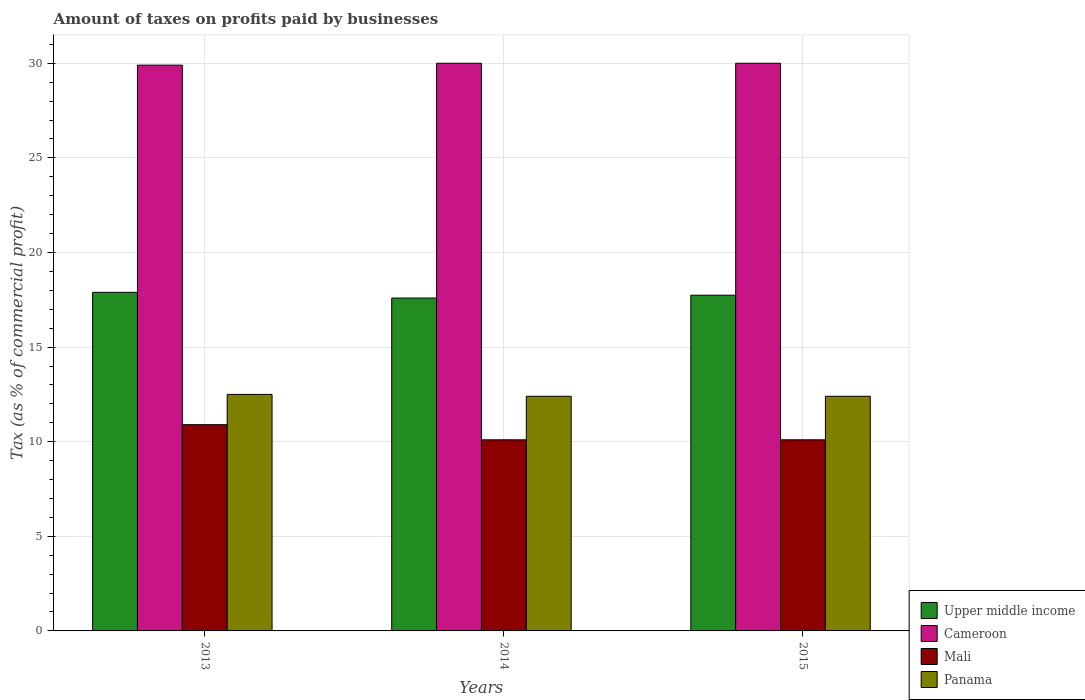How many groups of bars are there?
Your response must be concise. 3. Are the number of bars per tick equal to the number of legend labels?
Provide a short and direct response. Yes. Are the number of bars on each tick of the X-axis equal?
Offer a terse response. Yes. How many bars are there on the 3rd tick from the right?
Provide a succinct answer. 4. In how many cases, is the number of bars for a given year not equal to the number of legend labels?
Offer a terse response. 0. Across all years, what is the maximum percentage of taxes paid by businesses in Cameroon?
Offer a terse response. 30. Across all years, what is the minimum percentage of taxes paid by businesses in Panama?
Your answer should be very brief. 12.4. What is the total percentage of taxes paid by businesses in Mali in the graph?
Your response must be concise. 31.1. What is the difference between the percentage of taxes paid by businesses in Panama in 2013 and that in 2014?
Keep it short and to the point. 0.1. What is the difference between the percentage of taxes paid by businesses in Panama in 2015 and the percentage of taxes paid by businesses in Mali in 2014?
Offer a terse response. 2.3. What is the average percentage of taxes paid by businesses in Upper middle income per year?
Your answer should be very brief. 17.74. In the year 2014, what is the difference between the percentage of taxes paid by businesses in Panama and percentage of taxes paid by businesses in Mali?
Your answer should be very brief. 2.3. In how many years, is the percentage of taxes paid by businesses in Cameroon greater than 30 %?
Offer a very short reply. 0. What is the ratio of the percentage of taxes paid by businesses in Mali in 2014 to that in 2015?
Give a very brief answer. 1. Is the percentage of taxes paid by businesses in Panama in 2014 less than that in 2015?
Offer a terse response. No. What is the difference between the highest and the lowest percentage of taxes paid by businesses in Upper middle income?
Offer a terse response. 0.3. In how many years, is the percentage of taxes paid by businesses in Cameroon greater than the average percentage of taxes paid by businesses in Cameroon taken over all years?
Ensure brevity in your answer.  2. Is the sum of the percentage of taxes paid by businesses in Mali in 2013 and 2014 greater than the maximum percentage of taxes paid by businesses in Cameroon across all years?
Offer a very short reply. No. What does the 4th bar from the left in 2015 represents?
Your response must be concise. Panama. What does the 1st bar from the right in 2013 represents?
Ensure brevity in your answer.  Panama. Is it the case that in every year, the sum of the percentage of taxes paid by businesses in Panama and percentage of taxes paid by businesses in Cameroon is greater than the percentage of taxes paid by businesses in Upper middle income?
Your answer should be compact. Yes. Are all the bars in the graph horizontal?
Keep it short and to the point. No. Does the graph contain grids?
Provide a succinct answer. Yes. Where does the legend appear in the graph?
Your answer should be compact. Bottom right. What is the title of the graph?
Ensure brevity in your answer.  Amount of taxes on profits paid by businesses. What is the label or title of the Y-axis?
Your response must be concise. Tax (as % of commercial profit). What is the Tax (as % of commercial profit) in Upper middle income in 2013?
Provide a short and direct response. 17.89. What is the Tax (as % of commercial profit) in Cameroon in 2013?
Your answer should be very brief. 29.9. What is the Tax (as % of commercial profit) of Mali in 2013?
Your response must be concise. 10.9. What is the Tax (as % of commercial profit) of Upper middle income in 2014?
Keep it short and to the point. 17.59. What is the Tax (as % of commercial profit) of Cameroon in 2014?
Your answer should be compact. 30. What is the Tax (as % of commercial profit) in Mali in 2014?
Offer a very short reply. 10.1. What is the Tax (as % of commercial profit) of Upper middle income in 2015?
Give a very brief answer. 17.74. What is the Tax (as % of commercial profit) in Cameroon in 2015?
Provide a short and direct response. 30. Across all years, what is the maximum Tax (as % of commercial profit) of Upper middle income?
Give a very brief answer. 17.89. Across all years, what is the maximum Tax (as % of commercial profit) in Cameroon?
Your answer should be compact. 30. Across all years, what is the maximum Tax (as % of commercial profit) of Mali?
Give a very brief answer. 10.9. Across all years, what is the maximum Tax (as % of commercial profit) of Panama?
Your response must be concise. 12.5. Across all years, what is the minimum Tax (as % of commercial profit) in Upper middle income?
Provide a short and direct response. 17.59. Across all years, what is the minimum Tax (as % of commercial profit) of Cameroon?
Give a very brief answer. 29.9. Across all years, what is the minimum Tax (as % of commercial profit) in Mali?
Offer a very short reply. 10.1. What is the total Tax (as % of commercial profit) in Upper middle income in the graph?
Give a very brief answer. 53.23. What is the total Tax (as % of commercial profit) in Cameroon in the graph?
Make the answer very short. 89.9. What is the total Tax (as % of commercial profit) in Mali in the graph?
Your answer should be very brief. 31.1. What is the total Tax (as % of commercial profit) of Panama in the graph?
Make the answer very short. 37.3. What is the difference between the Tax (as % of commercial profit) in Upper middle income in 2013 and that in 2014?
Your answer should be very brief. 0.3. What is the difference between the Tax (as % of commercial profit) in Cameroon in 2013 and that in 2014?
Give a very brief answer. -0.1. What is the difference between the Tax (as % of commercial profit) of Upper middle income in 2013 and that in 2015?
Keep it short and to the point. 0.15. What is the difference between the Tax (as % of commercial profit) in Cameroon in 2013 and that in 2015?
Offer a very short reply. -0.1. What is the difference between the Tax (as % of commercial profit) of Panama in 2013 and that in 2015?
Your answer should be compact. 0.1. What is the difference between the Tax (as % of commercial profit) in Upper middle income in 2013 and the Tax (as % of commercial profit) in Cameroon in 2014?
Offer a terse response. -12.11. What is the difference between the Tax (as % of commercial profit) of Upper middle income in 2013 and the Tax (as % of commercial profit) of Mali in 2014?
Ensure brevity in your answer.  7.79. What is the difference between the Tax (as % of commercial profit) of Upper middle income in 2013 and the Tax (as % of commercial profit) of Panama in 2014?
Your response must be concise. 5.49. What is the difference between the Tax (as % of commercial profit) of Cameroon in 2013 and the Tax (as % of commercial profit) of Mali in 2014?
Your response must be concise. 19.8. What is the difference between the Tax (as % of commercial profit) of Mali in 2013 and the Tax (as % of commercial profit) of Panama in 2014?
Your response must be concise. -1.5. What is the difference between the Tax (as % of commercial profit) in Upper middle income in 2013 and the Tax (as % of commercial profit) in Cameroon in 2015?
Offer a terse response. -12.11. What is the difference between the Tax (as % of commercial profit) of Upper middle income in 2013 and the Tax (as % of commercial profit) of Mali in 2015?
Your answer should be very brief. 7.79. What is the difference between the Tax (as % of commercial profit) in Upper middle income in 2013 and the Tax (as % of commercial profit) in Panama in 2015?
Give a very brief answer. 5.49. What is the difference between the Tax (as % of commercial profit) in Cameroon in 2013 and the Tax (as % of commercial profit) in Mali in 2015?
Make the answer very short. 19.8. What is the difference between the Tax (as % of commercial profit) in Cameroon in 2013 and the Tax (as % of commercial profit) in Panama in 2015?
Offer a very short reply. 17.5. What is the difference between the Tax (as % of commercial profit) of Upper middle income in 2014 and the Tax (as % of commercial profit) of Cameroon in 2015?
Your response must be concise. -12.41. What is the difference between the Tax (as % of commercial profit) of Upper middle income in 2014 and the Tax (as % of commercial profit) of Mali in 2015?
Offer a very short reply. 7.49. What is the difference between the Tax (as % of commercial profit) in Upper middle income in 2014 and the Tax (as % of commercial profit) in Panama in 2015?
Make the answer very short. 5.19. What is the difference between the Tax (as % of commercial profit) of Cameroon in 2014 and the Tax (as % of commercial profit) of Panama in 2015?
Ensure brevity in your answer.  17.6. What is the difference between the Tax (as % of commercial profit) in Mali in 2014 and the Tax (as % of commercial profit) in Panama in 2015?
Give a very brief answer. -2.3. What is the average Tax (as % of commercial profit) of Upper middle income per year?
Your response must be concise. 17.74. What is the average Tax (as % of commercial profit) of Cameroon per year?
Ensure brevity in your answer.  29.97. What is the average Tax (as % of commercial profit) in Mali per year?
Provide a succinct answer. 10.37. What is the average Tax (as % of commercial profit) of Panama per year?
Provide a succinct answer. 12.43. In the year 2013, what is the difference between the Tax (as % of commercial profit) in Upper middle income and Tax (as % of commercial profit) in Cameroon?
Offer a very short reply. -12.01. In the year 2013, what is the difference between the Tax (as % of commercial profit) of Upper middle income and Tax (as % of commercial profit) of Mali?
Your answer should be very brief. 6.99. In the year 2013, what is the difference between the Tax (as % of commercial profit) of Upper middle income and Tax (as % of commercial profit) of Panama?
Make the answer very short. 5.39. In the year 2013, what is the difference between the Tax (as % of commercial profit) of Cameroon and Tax (as % of commercial profit) of Panama?
Your answer should be very brief. 17.4. In the year 2014, what is the difference between the Tax (as % of commercial profit) of Upper middle income and Tax (as % of commercial profit) of Cameroon?
Ensure brevity in your answer.  -12.41. In the year 2014, what is the difference between the Tax (as % of commercial profit) in Upper middle income and Tax (as % of commercial profit) in Mali?
Provide a short and direct response. 7.49. In the year 2014, what is the difference between the Tax (as % of commercial profit) of Upper middle income and Tax (as % of commercial profit) of Panama?
Your response must be concise. 5.19. In the year 2014, what is the difference between the Tax (as % of commercial profit) in Cameroon and Tax (as % of commercial profit) in Mali?
Provide a succinct answer. 19.9. In the year 2014, what is the difference between the Tax (as % of commercial profit) in Cameroon and Tax (as % of commercial profit) in Panama?
Make the answer very short. 17.6. In the year 2014, what is the difference between the Tax (as % of commercial profit) in Mali and Tax (as % of commercial profit) in Panama?
Provide a short and direct response. -2.3. In the year 2015, what is the difference between the Tax (as % of commercial profit) of Upper middle income and Tax (as % of commercial profit) of Cameroon?
Give a very brief answer. -12.26. In the year 2015, what is the difference between the Tax (as % of commercial profit) in Upper middle income and Tax (as % of commercial profit) in Mali?
Give a very brief answer. 7.64. In the year 2015, what is the difference between the Tax (as % of commercial profit) of Upper middle income and Tax (as % of commercial profit) of Panama?
Offer a terse response. 5.34. In the year 2015, what is the difference between the Tax (as % of commercial profit) of Cameroon and Tax (as % of commercial profit) of Mali?
Your response must be concise. 19.9. In the year 2015, what is the difference between the Tax (as % of commercial profit) of Cameroon and Tax (as % of commercial profit) of Panama?
Make the answer very short. 17.6. What is the ratio of the Tax (as % of commercial profit) of Upper middle income in 2013 to that in 2014?
Keep it short and to the point. 1.02. What is the ratio of the Tax (as % of commercial profit) of Mali in 2013 to that in 2014?
Offer a terse response. 1.08. What is the ratio of the Tax (as % of commercial profit) in Panama in 2013 to that in 2014?
Keep it short and to the point. 1.01. What is the ratio of the Tax (as % of commercial profit) of Upper middle income in 2013 to that in 2015?
Provide a succinct answer. 1.01. What is the ratio of the Tax (as % of commercial profit) in Cameroon in 2013 to that in 2015?
Your response must be concise. 1. What is the ratio of the Tax (as % of commercial profit) of Mali in 2013 to that in 2015?
Ensure brevity in your answer.  1.08. What is the ratio of the Tax (as % of commercial profit) of Panama in 2013 to that in 2015?
Keep it short and to the point. 1.01. What is the ratio of the Tax (as % of commercial profit) in Upper middle income in 2014 to that in 2015?
Provide a short and direct response. 0.99. What is the ratio of the Tax (as % of commercial profit) in Mali in 2014 to that in 2015?
Offer a terse response. 1. What is the ratio of the Tax (as % of commercial profit) of Panama in 2014 to that in 2015?
Provide a succinct answer. 1. What is the difference between the highest and the second highest Tax (as % of commercial profit) in Upper middle income?
Your answer should be very brief. 0.15. What is the difference between the highest and the second highest Tax (as % of commercial profit) in Cameroon?
Keep it short and to the point. 0. What is the difference between the highest and the second highest Tax (as % of commercial profit) of Panama?
Provide a succinct answer. 0.1. What is the difference between the highest and the lowest Tax (as % of commercial profit) in Upper middle income?
Make the answer very short. 0.3. What is the difference between the highest and the lowest Tax (as % of commercial profit) of Cameroon?
Offer a very short reply. 0.1. 